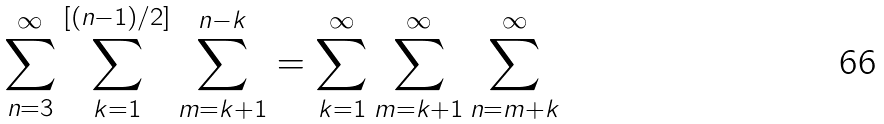<formula> <loc_0><loc_0><loc_500><loc_500>\sum _ { n = 3 } ^ { \infty } \sum _ { k = 1 } ^ { [ ( n - 1 ) / 2 ] } \sum _ { m = k + 1 } ^ { n - k } = \sum _ { k = 1 } ^ { \infty } \sum _ { m = k + 1 } ^ { \infty } \sum _ { n = m + k } ^ { \infty }</formula> 